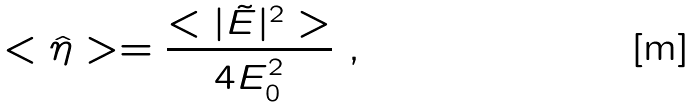<formula> <loc_0><loc_0><loc_500><loc_500>< \hat { \eta } > = \frac { < | \tilde { E } | ^ { 2 } > } { 4 E _ { 0 } ^ { 2 } } \ ,</formula> 